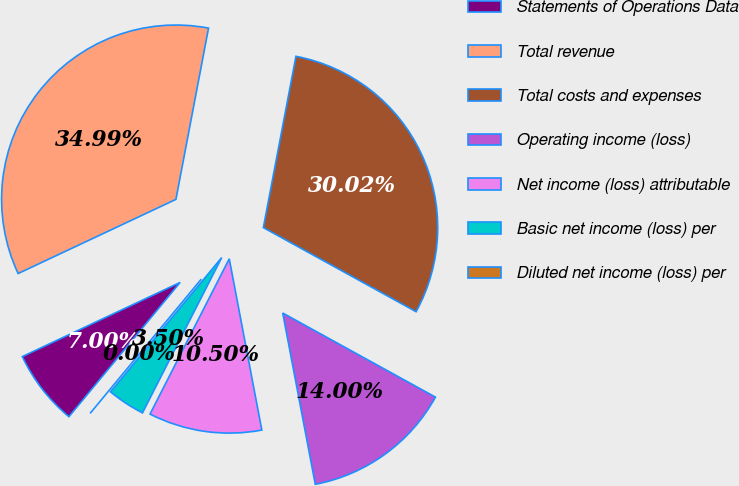<chart> <loc_0><loc_0><loc_500><loc_500><pie_chart><fcel>Statements of Operations Data<fcel>Total revenue<fcel>Total costs and expenses<fcel>Operating income (loss)<fcel>Net income (loss) attributable<fcel>Basic net income (loss) per<fcel>Diluted net income (loss) per<nl><fcel>7.0%<fcel>34.99%<fcel>30.02%<fcel>14.0%<fcel>10.5%<fcel>3.5%<fcel>0.0%<nl></chart> 